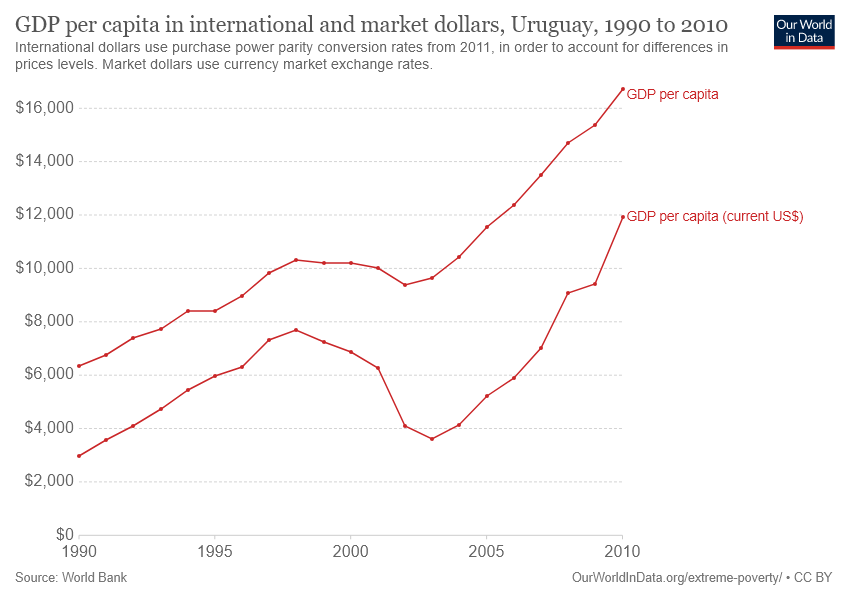Outline some significant characteristics in this image. The starting year of the GDP comparison mentioned in the graph was 1990. The year with the highest GDP per capita was 2010. 